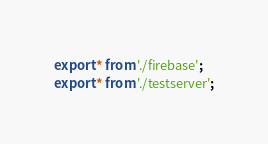<code> <loc_0><loc_0><loc_500><loc_500><_TypeScript_>export * from './firebase';
export * from './testserver';
</code> 